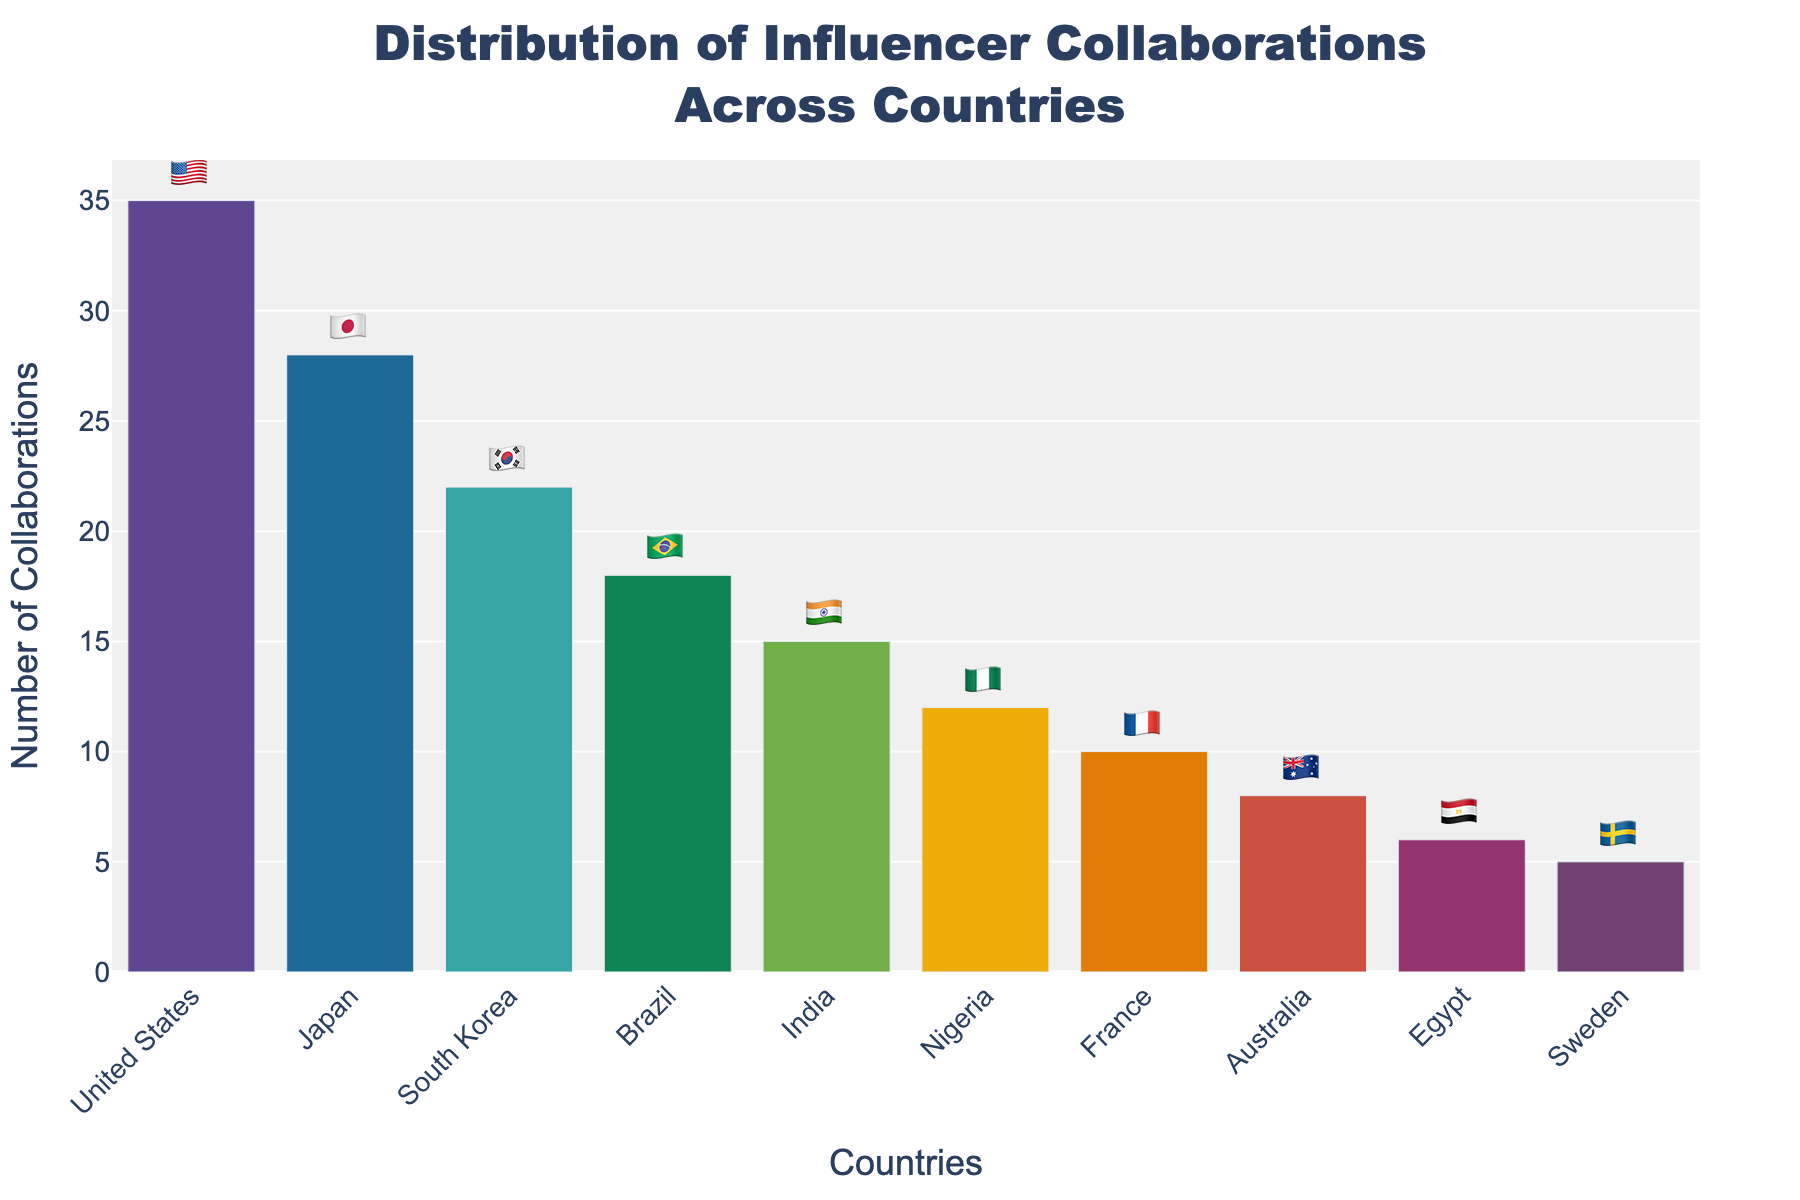what is the title of the chart? Look at the top of the chart where the main heading is located. The title is "Distribution of Influencer Collaborations Across Countries".
Answer: Distribution of Influencer Collaborations Across Countries Which country has the highest number of collaborations? Look at the tallest bar in the chart, which represents the country with the highest number. The bar for the United States is the tallest with 35 collaborations.
Answer: United States How many countries are represented in the chart? Count the bars or the country names listed on the x-axis of the chart. There are 10 countries represented.
Answer: 10 What is the combined total number of collaborations for Japan and South Korea? Look at the bars for Japan (28 collaborations) and South Korea (22 collaborations) and sum them up. 28 + 22 = 50.
Answer: 50 Which country has more collaborations, Brazil or India? Compare the height of the bars for Brazil and India. Brazil has 18 collaborations, while India has 15 collaborations.
Answer: Brazil What is the average number of collaborations across all countries? First, sum up the number of collaborations for all countries: 35 + 28 + 22 + 18 + 15 + 12 + 10 + 8 + 6 + 5 = 159. Then, divide by the number of countries (10): 159 / 10 = 15.9.
Answer: 15.9 Which countries have fewer than 10 collaborations? Look at the bars representing the number of collaborations. Egypt (6 collaborations) and Sweden (5 collaborations) have fewer than 10 collaborations.
Answer: Egypt, Sweden What's the difference in the number of collaborations between the country with the highest and the country with the lowest number? The United States has the highest number of collaborations (35), and Sweden has the lowest (5). The difference is 35 - 5 = 30.
Answer: 30 How many more collaborations does South Korea have compared to Nigeria? South Korea has 22 collaborations, and Nigeria has 12. The difference is 22 - 12 = 10.
Answer: 10 In which country would you find the 🇫🇷 emoji in this chart? Look at the bar labels. The 🇫🇷 emoji corresponds to France, which has 10 collaborations.
Answer: France 